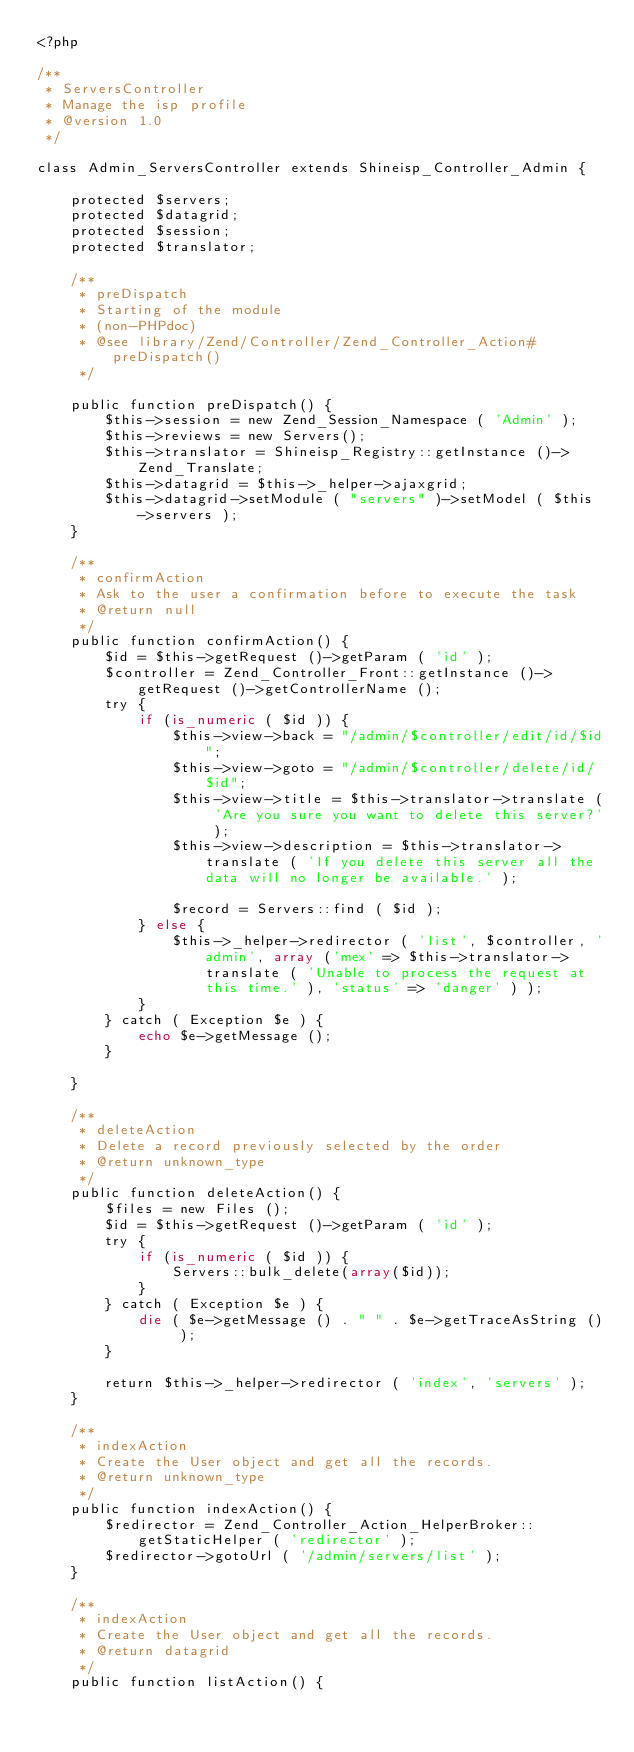<code> <loc_0><loc_0><loc_500><loc_500><_PHP_><?php

/**
 * ServersController
 * Manage the isp profile
 * @version 1.0
 */

class Admin_ServersController extends Shineisp_Controller_Admin {
	
	protected $servers;
	protected $datagrid;
	protected $session;
	protected $translator;
	
	/**
	 * preDispatch
	 * Starting of the module
	 * (non-PHPdoc)
	 * @see library/Zend/Controller/Zend_Controller_Action#preDispatch()
	 */
	
	public function preDispatch() {
		$this->session = new Zend_Session_Namespace ( 'Admin' );
		$this->reviews = new Servers();
		$this->translator = Shineisp_Registry::getInstance ()->Zend_Translate;
		$this->datagrid = $this->_helper->ajaxgrid;
		$this->datagrid->setModule ( "servers" )->setModel ( $this->servers );		
	}
	
	/**
	 * confirmAction
	 * Ask to the user a confirmation before to execute the task
	 * @return null
	 */
	public function confirmAction() {
		$id = $this->getRequest ()->getParam ( 'id' );
		$controller = Zend_Controller_Front::getInstance ()->getRequest ()->getControllerName ();
		try {
			if (is_numeric ( $id )) {
				$this->view->back = "/admin/$controller/edit/id/$id";
				$this->view->goto = "/admin/$controller/delete/id/$id";
				$this->view->title = $this->translator->translate ( 'Are you sure you want to delete this server?' );
				$this->view->description = $this->translator->translate ( 'If you delete this server all the data will no longer be available.' );
				
				$record = Servers::find ( $id );
			} else {
				$this->_helper->redirector ( 'list', $controller, 'admin', array ('mex' => $this->translator->translate ( 'Unable to process the request at this time.' ), 'status' => 'danger' ) );
			}
		} catch ( Exception $e ) {
			echo $e->getMessage ();
		}
	
	}
	
	/**
	 * deleteAction
	 * Delete a record previously selected by the order
	 * @return unknown_type
	 */
	public function deleteAction() {
		$files = new Files ();
		$id = $this->getRequest ()->getParam ( 'id' );
		try {
			if (is_numeric ( $id )) {
				Servers::bulk_delete(array($id));
			}
		} catch ( Exception $e ) {
			die ( $e->getMessage () . " " . $e->getTraceAsString () );
		}
		
		return $this->_helper->redirector ( 'index', 'servers' );
	}	
	
	/**
	 * indexAction
	 * Create the User object and get all the records.
	 * @return unknown_type
	 */
	public function indexAction() {
		$redirector = Zend_Controller_Action_HelperBroker::getStaticHelper ( 'redirector' );
		$redirector->gotoUrl ( '/admin/servers/list' );
	}
	
	/**
	 * indexAction
	 * Create the User object and get all the records.
	 * @return datagrid
	 */
	public function listAction() {</code> 